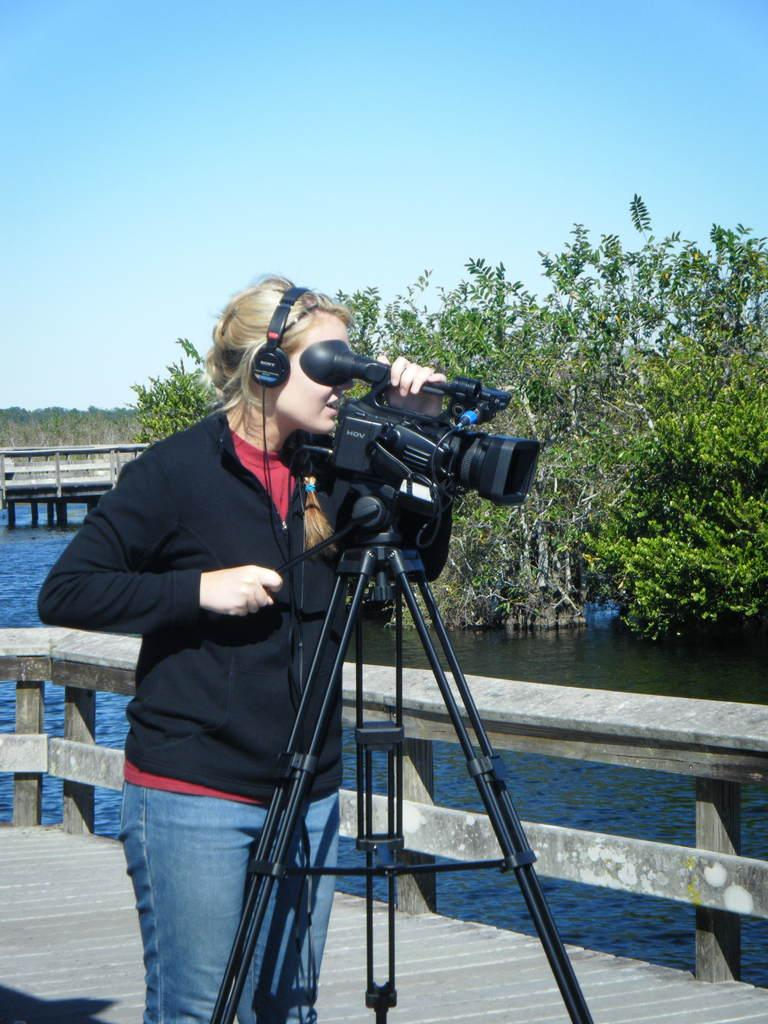Who is present in the image? There is a woman in the image. What is the woman doing in the image? The woman is standing on the floor and holding a camera with her hand. How is the camera positioned in the image? The camera is on a tripod stand. What can be seen in the background of the image? There is a platform, trees, water, and the sky visible in the background of the image. What type of brass instruments are the boys playing in the image? There are no boys or brass instruments present in the image. 